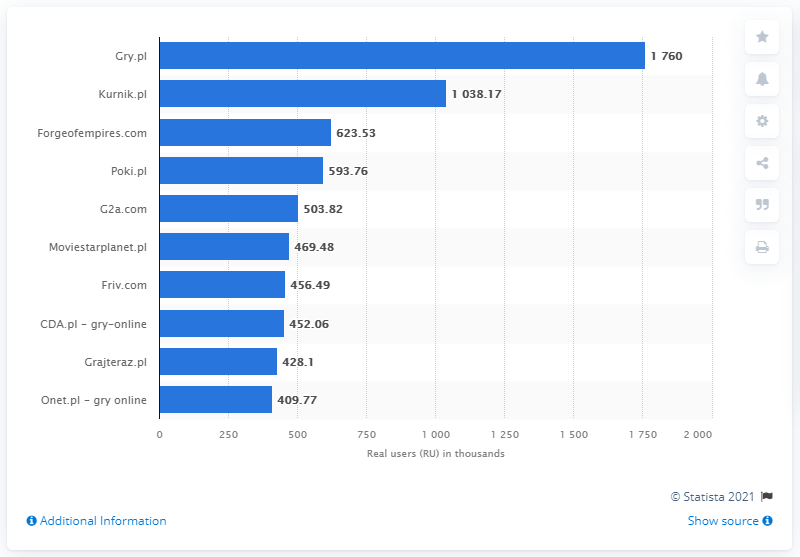Point out several critical features in this image. According to the data available in February 2020, Gry.pl was the most popular website for online games in Poland. 